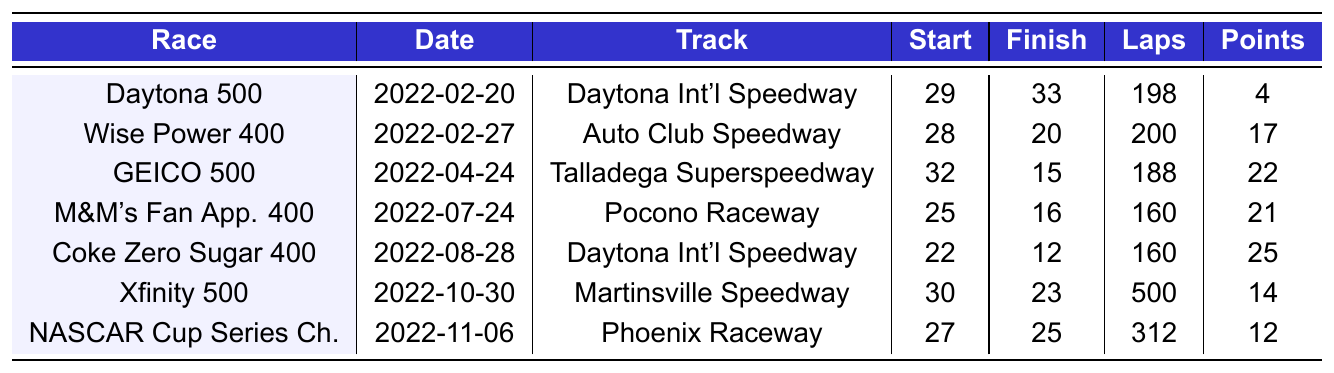What was Todd Gilliland's finishing position in the Daytona 500? The Daytona 500 is listed in the table as race number 1. Todd Gilliland's finishing position for this race is noted as 33.
Answer: 33 How many laps did Todd Gilliland complete in the Coke Zero Sugar 400? The Coke Zero Sugar 400 is race number 26, and the table shows he completed 160 laps in that race.
Answer: 160 What was Todd Gilliland's starting position in the GEICO 500? The GEICO 500 is the third race listed in the table, and Todd Gilliland started in position 32 for this race.
Answer: 32 Did Todd Gilliland earn more points in the M&M's Fan Appreciation 400 than in the Xfinity 500? In the M&M's Fan Appreciation 400, he earned 21 points, while he earned 14 points in the Xfinity 500. Since 21 is greater than 14, the answer is yes.
Answer: Yes What is the average number of laps completed across all races listed? The laps completed are: 198, 200, 188, 160, 160, 500, and 312. Adding these gives a total of 1718 laps. There are 7 races, so the average is 1718 divided by 7, which is approximately 245.43.
Answer: 245.43 Which race did Todd Gilliland finish the highest, and what was his position? Reviewing the table, the highest finishing position is 12 in the Coke Zero Sugar 400. This is the best position recorded among the races listed.
Answer: 12 in the Coke Zero Sugar 400 What is the difference in points earned between the first and last races listed in the table? In the first race (Daytona 500), he earned 4 points, and in the last race (NASCAR Cup Series Championship), he earned 12 points. The difference is 12 - 4 = 8 points.
Answer: 8 In how many races did Todd Gilliland finish in a position higher than 20? Analyzing the finishing positions, he finished higher than 20 in the Wise Power 400 (20), GEICO 500 (15), M&M's Fan Appreciation 400 (16), and Coke Zero Sugar 400 (12). So, he finished higher than 20 in 4 races (not counting 20).
Answer: 4 Was there a race where he completed more laps than the total of 200 laps? The Xfinity 500 was the only race where he completed 500 laps, which is more than 200. Hence, the answer is yes.
Answer: Yes What track hosted the race where Todd Gilliland earned the most points? In the Coke Zero Sugar 400, he earned the most points, which was 25. The table indicates this race took place at Daytona International Speedway.
Answer: Daytona International Speedway 